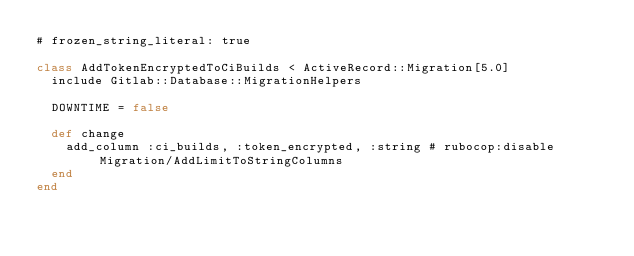<code> <loc_0><loc_0><loc_500><loc_500><_Ruby_># frozen_string_literal: true

class AddTokenEncryptedToCiBuilds < ActiveRecord::Migration[5.0]
  include Gitlab::Database::MigrationHelpers

  DOWNTIME = false

  def change
    add_column :ci_builds, :token_encrypted, :string # rubocop:disable Migration/AddLimitToStringColumns
  end
end
</code> 